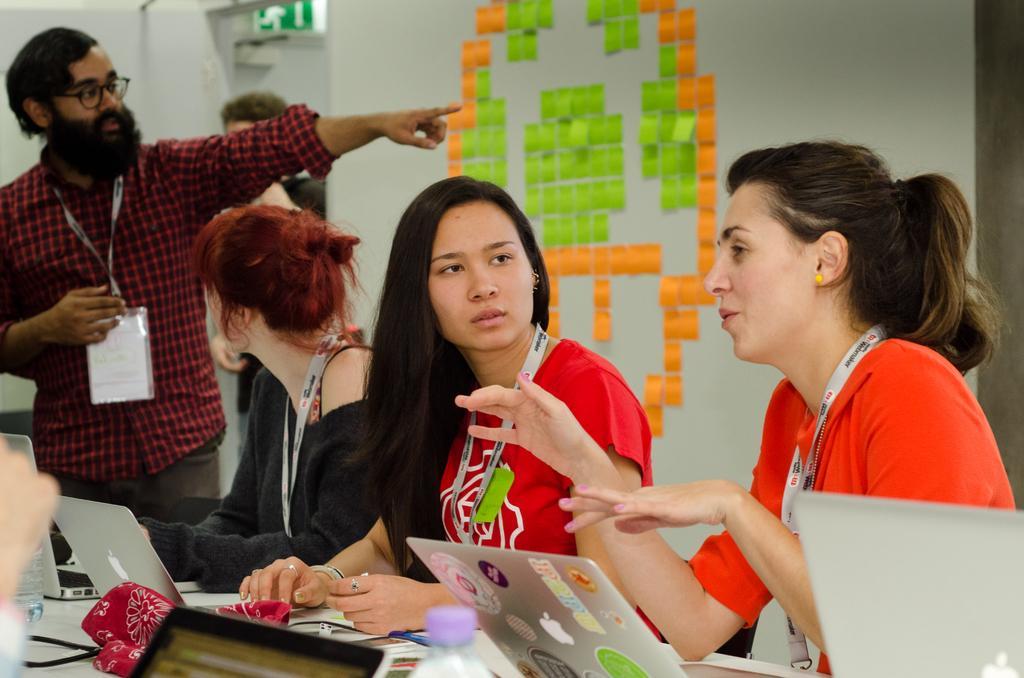Can you describe this image briefly? In this picture there are people, among them there are three women sitting and we can see laptops, bottles and objects on the table. In the background of the image we can see stickers on the wall and board. 